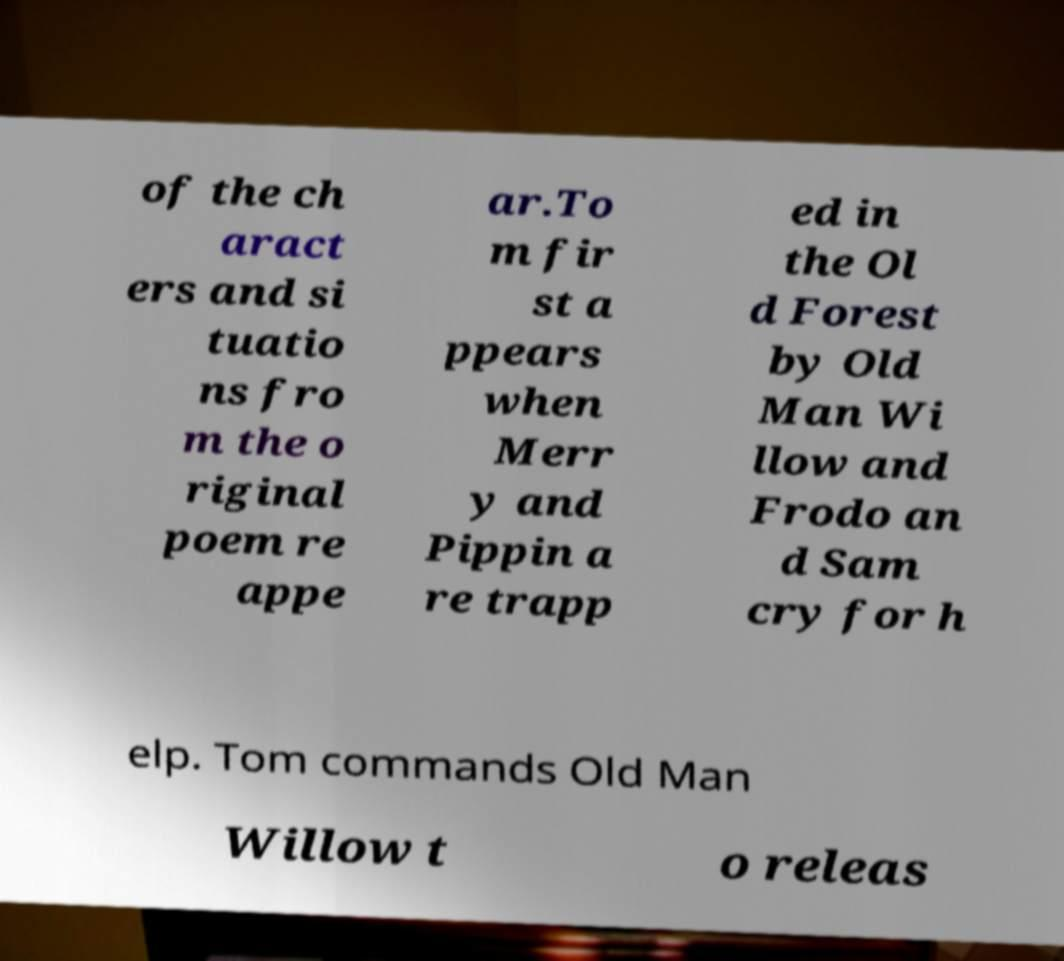What messages or text are displayed in this image? I need them in a readable, typed format. of the ch aract ers and si tuatio ns fro m the o riginal poem re appe ar.To m fir st a ppears when Merr y and Pippin a re trapp ed in the Ol d Forest by Old Man Wi llow and Frodo an d Sam cry for h elp. Tom commands Old Man Willow t o releas 